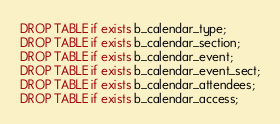<code> <loc_0><loc_0><loc_500><loc_500><_SQL_>DROP TABLE if exists b_calendar_type;
DROP TABLE if exists b_calendar_section;
DROP TABLE if exists b_calendar_event;
DROP TABLE if exists b_calendar_event_sect;
DROP TABLE if exists b_calendar_attendees;
DROP TABLE if exists b_calendar_access;
</code> 